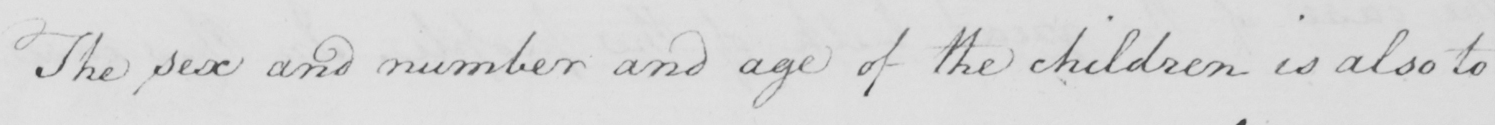Please transcribe the handwritten text in this image. The sex and number and age of the children is also to 